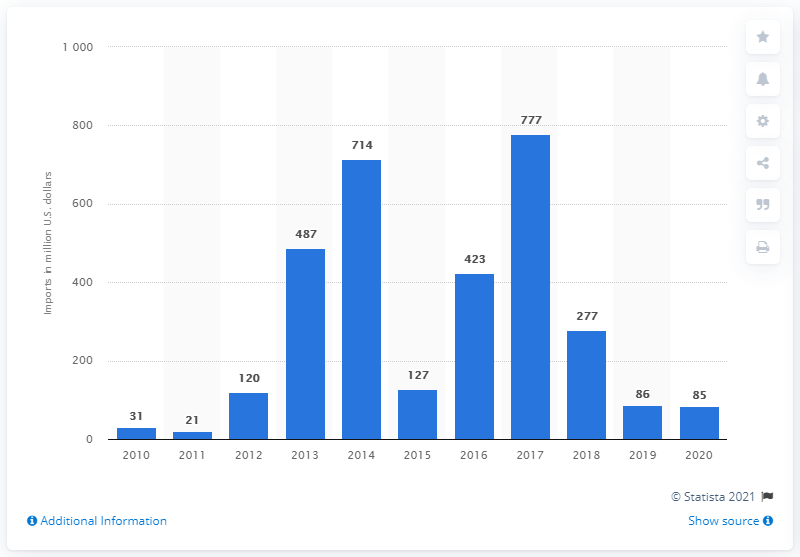Outline some significant characteristics in this image. In 2012, the value of Oman's arms imports was $85 million. 